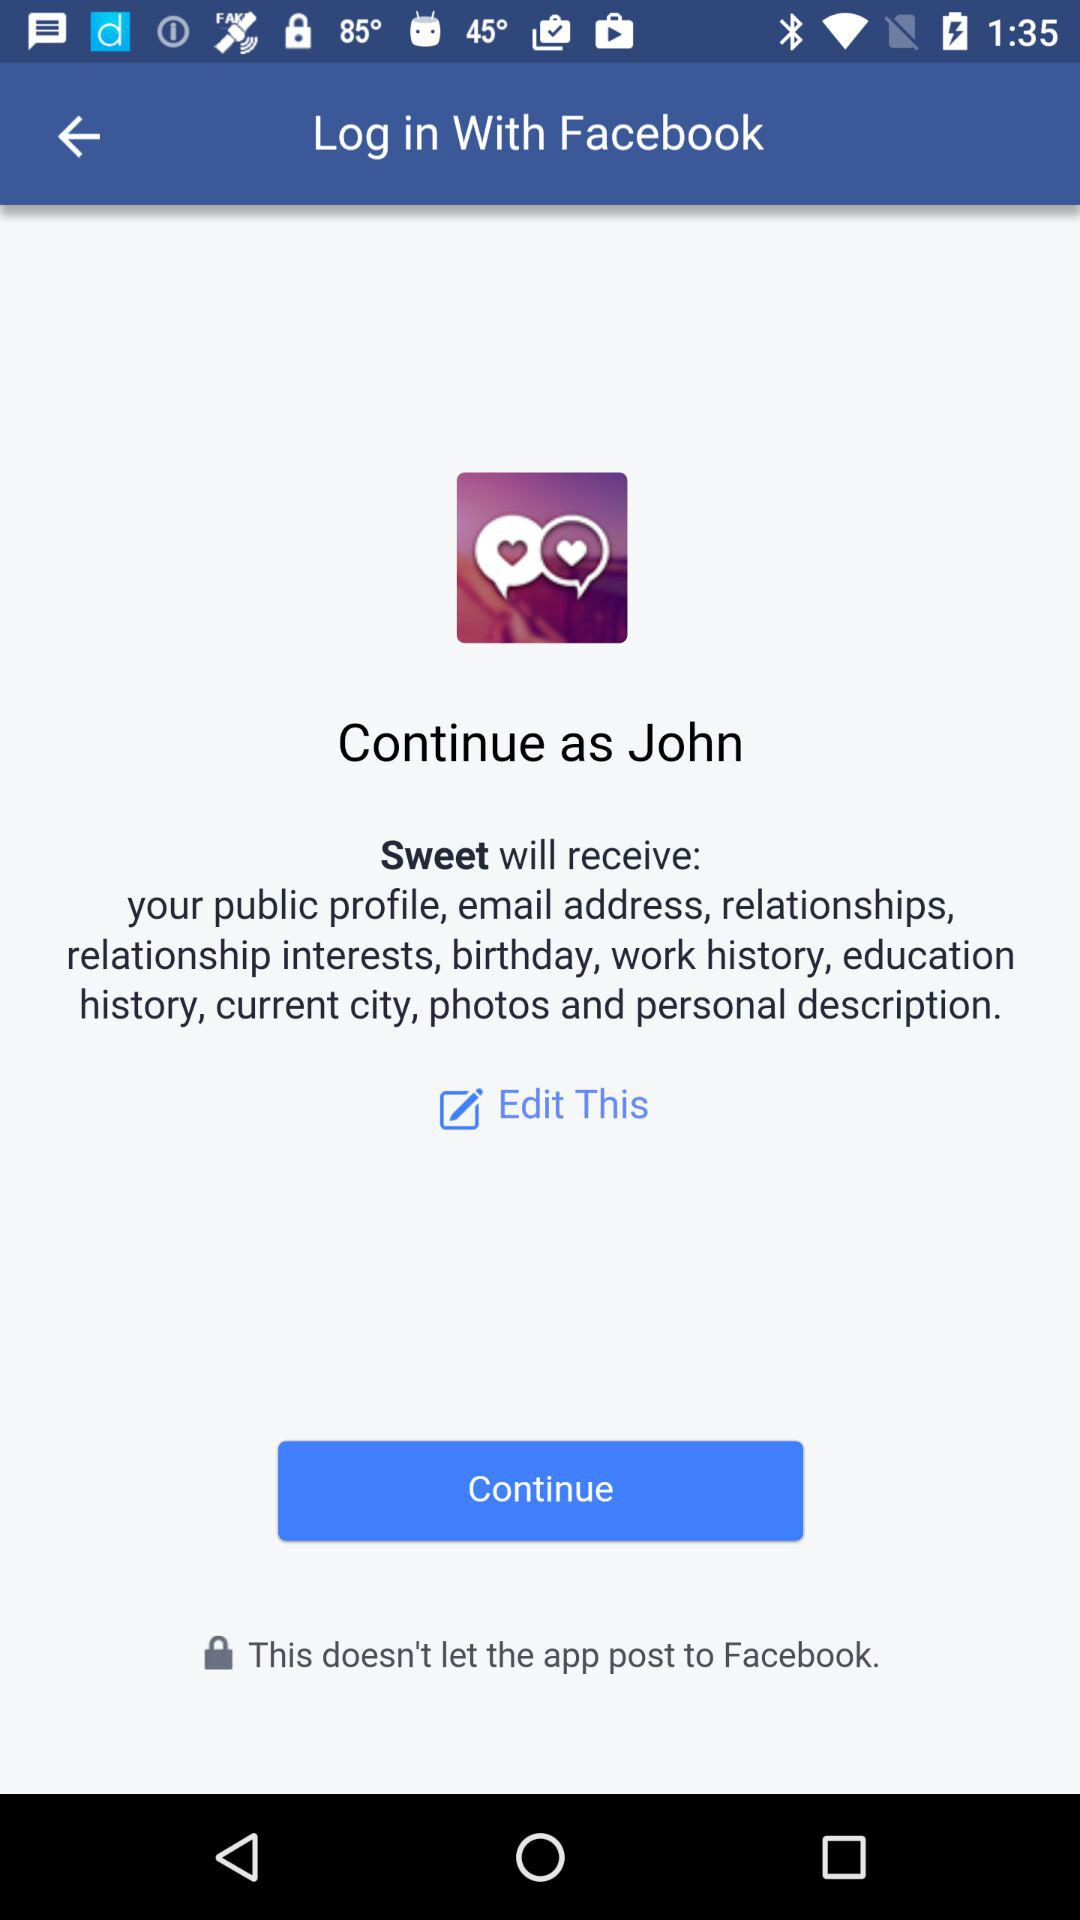What's the user name? The user name is John. 